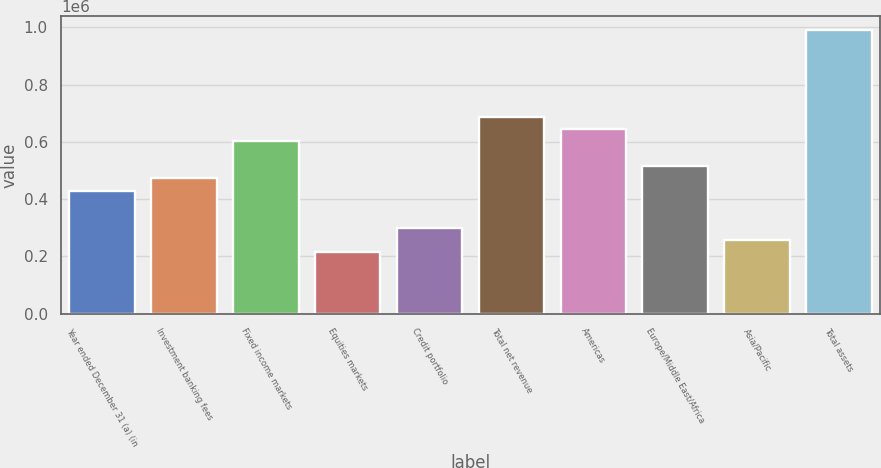Convert chart. <chart><loc_0><loc_0><loc_500><loc_500><bar_chart><fcel>Year ended December 31 (a) (in<fcel>Investment banking fees<fcel>Fixed income markets<fcel>Equities markets<fcel>Credit portfolio<fcel>Total net revenue<fcel>Americas<fcel>Europe/Middle East/Africa<fcel>Asia/Pacific<fcel>Total assets<nl><fcel>429866<fcel>472852<fcel>601811<fcel>214935<fcel>300907<fcel>687784<fcel>644797<fcel>515839<fcel>257921<fcel>988688<nl></chart> 